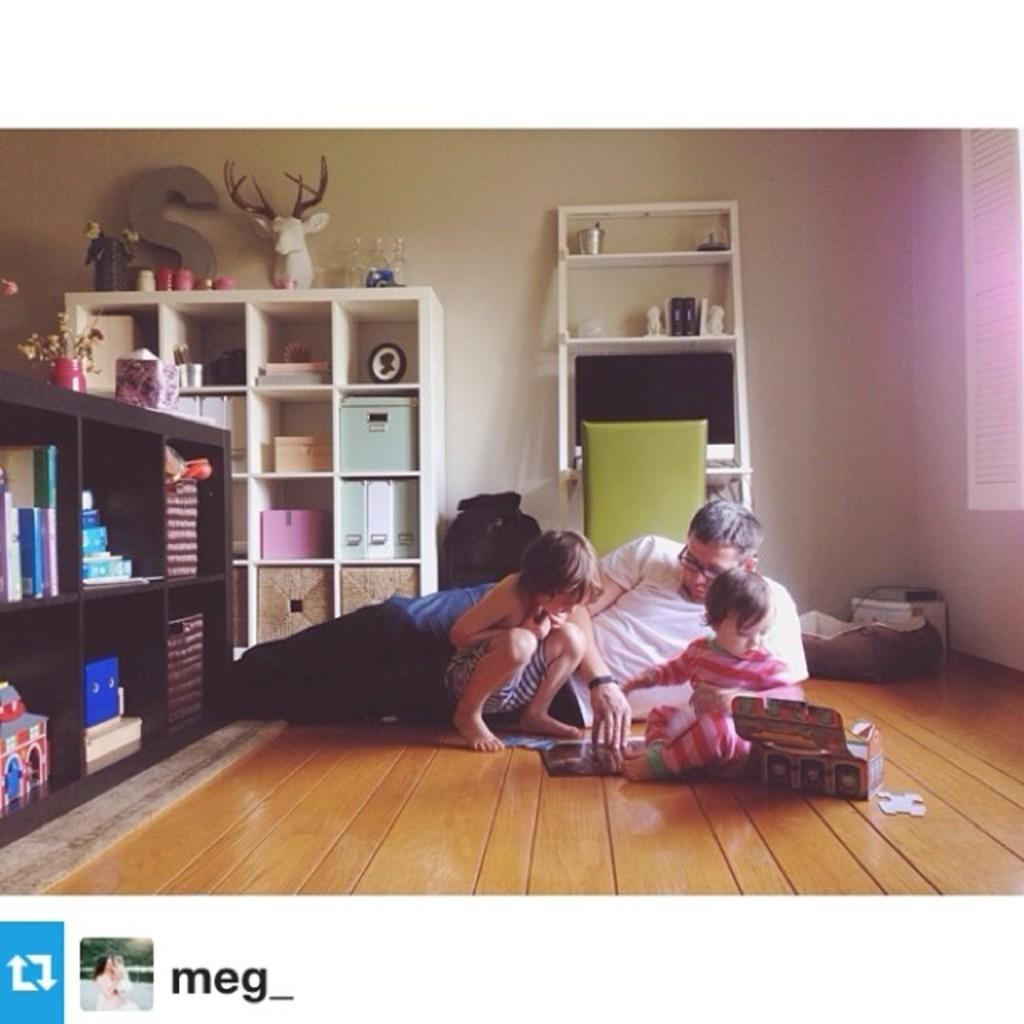Provide a one-sentence caption for the provided image. A man lays on the floor with two young children playing in a scene posted by Meg_. 